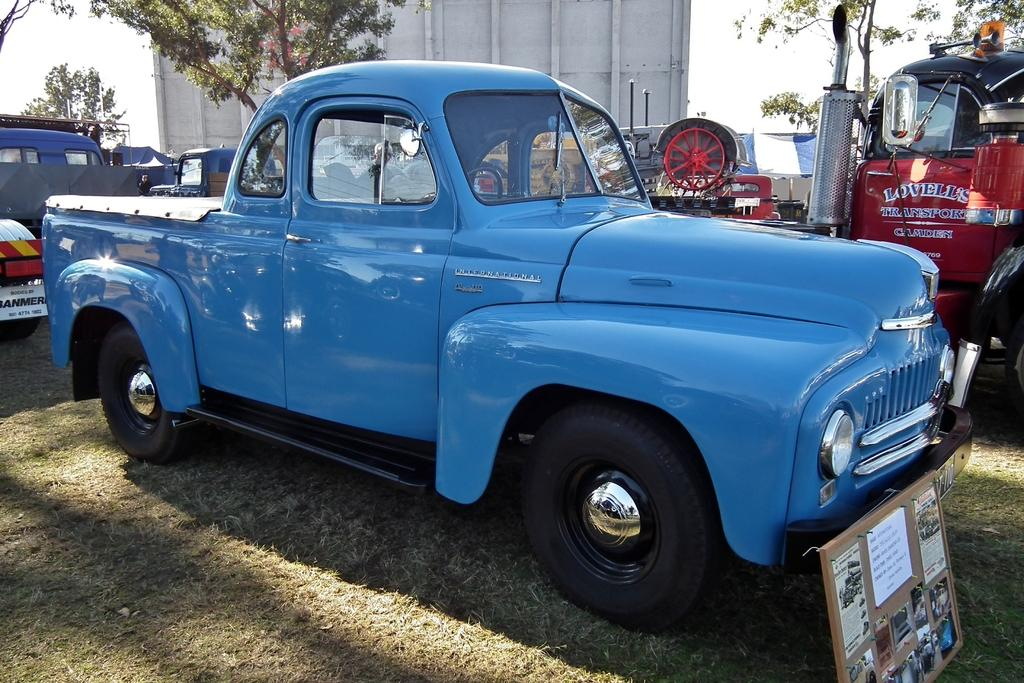What is located on the grass in the image? There are vehicles on the grass in the image. What can be seen on the right side of the image? There is a board on the right side of the image. What type of natural vegetation is visible in the image? There are trees visible in the image. What is in the background of the image? There is a wall in the background of the image. What is visible at the top of the image? The sky is visible at the top of the image. What type of jam is being spread on the sidewalk in the image? There is no sidewalk or jam present in the image. How many thumbs can be seen interacting with the vehicles on the grass? There is no reference to thumbs or their interaction with the vehicles in the image. 